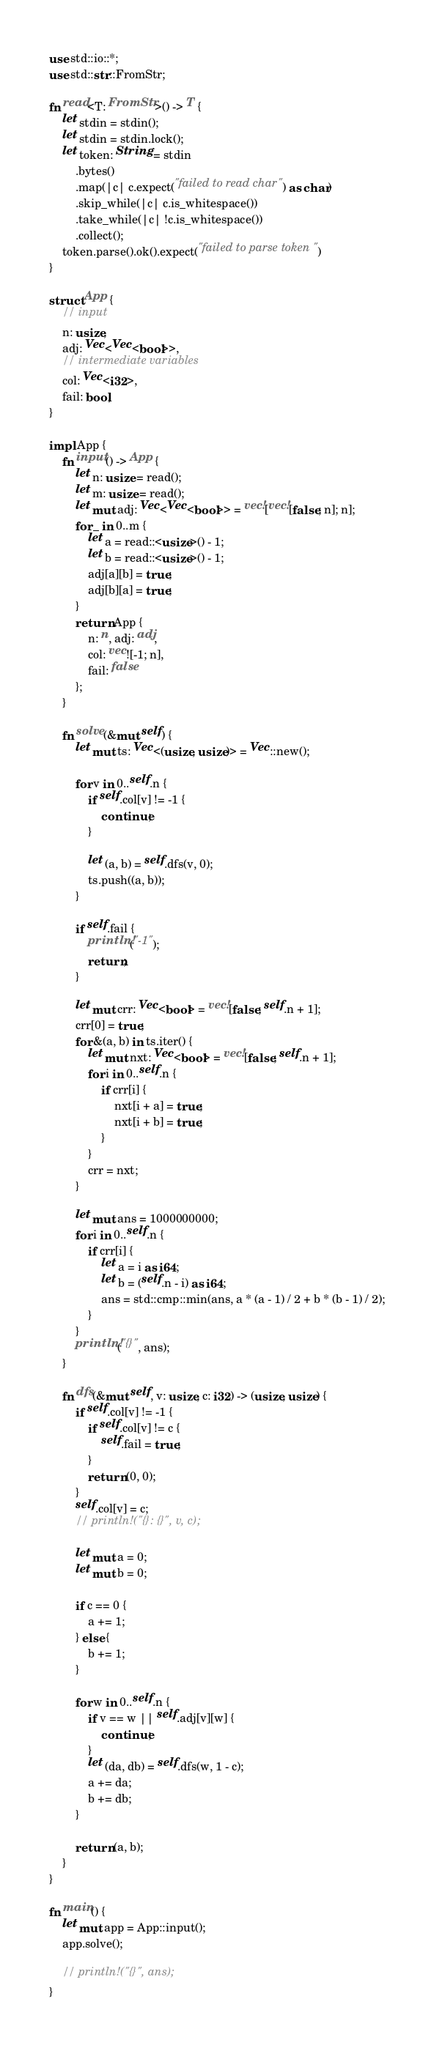Convert code to text. <code><loc_0><loc_0><loc_500><loc_500><_Rust_>use std::io::*;
use std::str::FromStr;

fn read<T: FromStr>() -> T {
    let stdin = stdin();
    let stdin = stdin.lock();
    let token: String = stdin
        .bytes()
        .map(|c| c.expect("failed to read char") as char)
        .skip_while(|c| c.is_whitespace())
        .take_while(|c| !c.is_whitespace())
        .collect();
    token.parse().ok().expect("failed to parse token")
}

struct App {
    // input
    n: usize,
    adj: Vec<Vec<bool>>,
    // intermediate variables
    col: Vec<i32>,
    fail: bool,
}

impl App {
    fn input() -> App {
        let n: usize = read();
        let m: usize = read();
        let mut adj: Vec<Vec<bool>> = vec![vec![false; n]; n];
        for _ in 0..m {
            let a = read::<usize>() - 1;
            let b = read::<usize>() - 1;
            adj[a][b] = true;
            adj[b][a] = true;
        }
        return App {
            n: n, adj: adj,
            col: vec![-1; n],
            fail: false
        };
    }

    fn solve(&mut self) {
        let mut ts: Vec<(usize, usize)> = Vec::new();

        for v in 0..self.n {
            if self.col[v] != -1 {
                continue;
            }

            let (a, b) = self.dfs(v, 0);
            ts.push((a, b));
        }

        if self.fail {
            println!("-1");
            return;
        }

        let mut crr: Vec<bool> = vec![false; self.n + 1];
        crr[0] = true;
        for &(a, b) in ts.iter() {
            let mut nxt: Vec<bool> = vec![false; self.n + 1];
            for i in 0..self.n {
                if crr[i] {
                    nxt[i + a] = true;
                    nxt[i + b] = true;
                }
            }
            crr = nxt;
        }

        let mut ans = 1000000000;
        for i in 0..self.n {
            if crr[i] {
                let a = i as i64;
                let b = (self.n - i) as i64;
                ans = std::cmp::min(ans, a * (a - 1) / 2 + b * (b - 1) / 2);
            }
        }
        println!("{}", ans);
    }

    fn dfs(&mut self, v: usize, c: i32) -> (usize, usize) {
        if self.col[v] != -1 {
            if self.col[v] != c {
                self.fail = true;
            }
            return (0, 0);
        }
        self.col[v] = c;
        // println!("{}: {}", v, c);

        let mut a = 0;
        let mut b = 0;

        if c == 0 {
            a += 1;
        } else {
            b += 1;
        }

        for w in 0..self.n {
            if v == w || self.adj[v][w] {
                continue;
            }
            let (da, db) = self.dfs(w, 1 - c);
            a += da;
            b += db;
        }

        return (a, b);
    }
}

fn main() {
    let mut app = App::input();
    app.solve();

    // println!("{}", ans);
}
</code> 